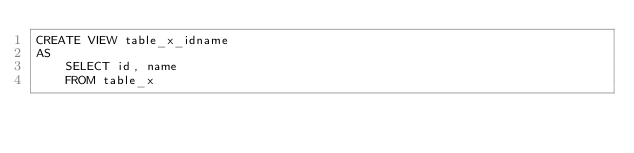<code> <loc_0><loc_0><loc_500><loc_500><_SQL_>CREATE VIEW table_x_idname
AS
    SELECT id, name
    FROM table_x</code> 